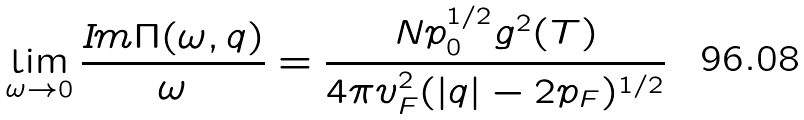Convert formula to latex. <formula><loc_0><loc_0><loc_500><loc_500>\lim _ { \omega \rightarrow 0 } \frac { { \mbox I m } \Pi ( \omega , { q } ) } { \omega } = \frac { N p _ { 0 } ^ { 1 / 2 } g ^ { 2 } ( T ) } { 4 \pi v _ { F } ^ { 2 } ( | q | - 2 p _ { F } ) ^ { 1 / 2 } }</formula> 